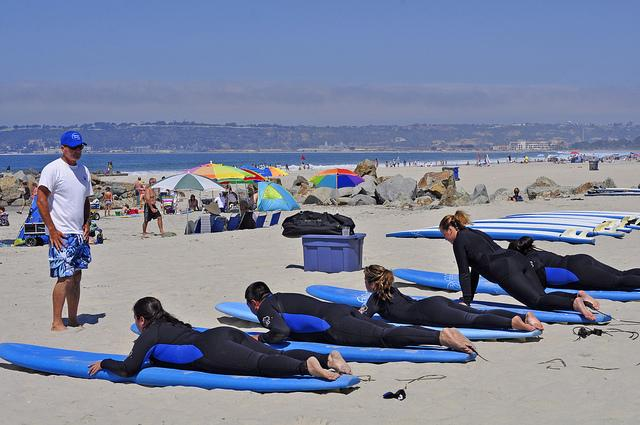What are the people on the blue boards doing?

Choices:
A) sleeping
B) eating
C) practicing
D) tanning practicing 